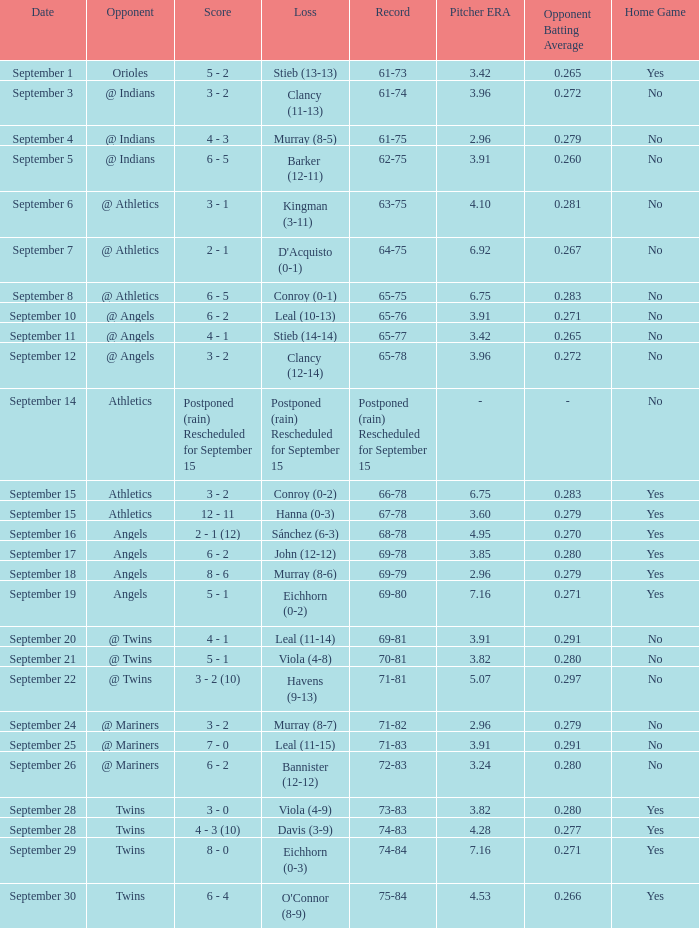Name the score which has record of 73-83 3 - 0. 